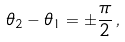Convert formula to latex. <formula><loc_0><loc_0><loc_500><loc_500>\theta _ { 2 } - \theta _ { 1 } = \pm \frac { \pi } { 2 } \, ,</formula> 